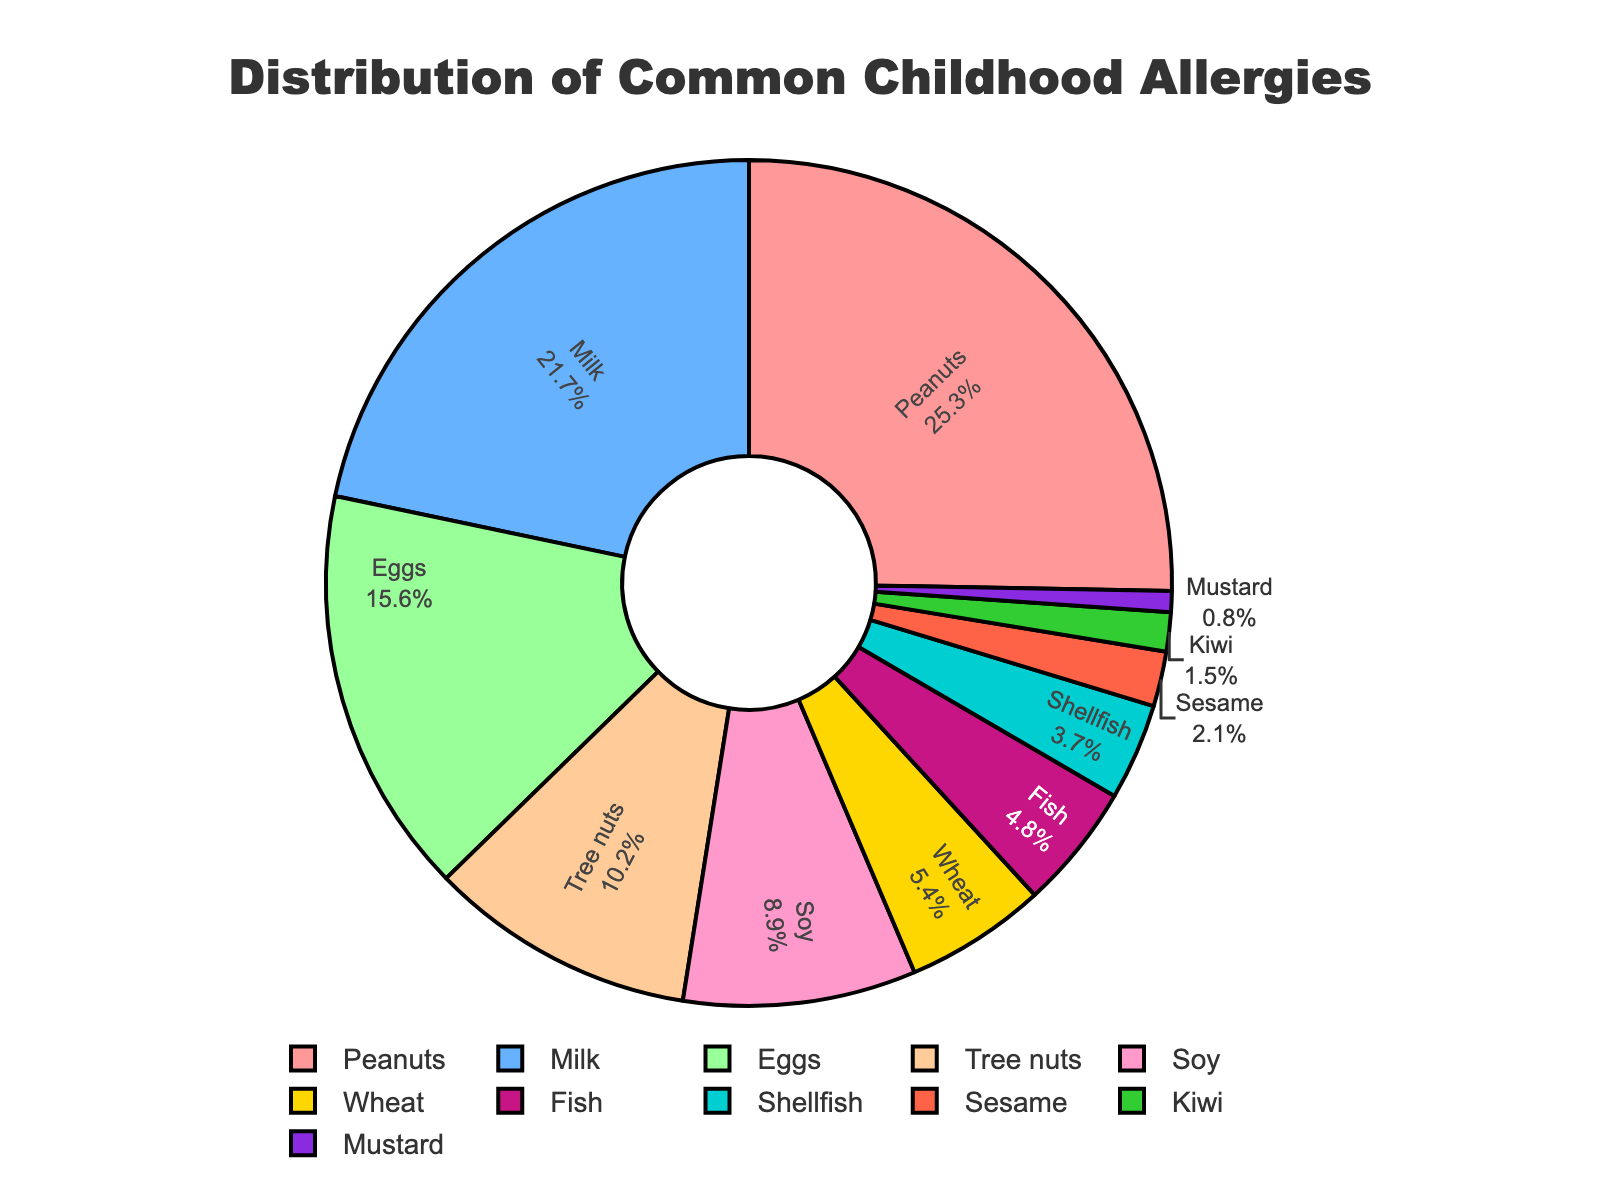What's the percentage of childhood allergies caused by peanuts and milk combined? To calculate the combined percentage, simply add the percentage values for peanuts and milk. Peanuts account for 25.3%, and milk accounts for 21.7%. So, the combined percentage is 25.3 + 21.7 = 47.0%.
Answer: 47.0% Which allergen has the lowest percentage? To determine the allergen with the lowest percentage, examine the percentages listed in the pie chart. Mustard has the lowest percentage at 0.8%.
Answer: Mustard How does the percentage of tree nut allergies compare to soy allergies? Compare the two percentages provided in the pie chart. Tree nuts account for 10.2%, whereas soy accounts for 8.9%. Therefore, the percentage of tree nut allergies is higher than soy allergies.
Answer: Tree nuts have a higher percentage Which allergens together make up more than 50% of childhood allergies? To identify the allergens that together account for more than 50%, start adding the largest percentages until the sum exceeds 50%. Combining peanuts (25.3%), milk (21.7%), and eggs (15.6%) gives 25.3 + 21.7 + 15.6 = 62.6%, which is over 50%.
Answer: Peanuts, milk, and eggs What is the third most common childhood allergen? Identify the allergen with the third highest percentage. The list shows that eggs, with 15.6%, are the third most common childhood allergen after peanuts and milk.
Answer: Eggs What is the difference in percentage between fish and shellfish allergies? Subtract the percentage of shellfish allergies from fish allergies. Fish have 4.8%, while shellfish have 3.7%. Thus, the difference is 4.8 - 3.7 = 1.1%.
Answer: 1.1% Is the percentage of wheat allergies higher or lower than sesame allergies? Compare the percentages of wheat (5.4%) and sesame (2.1%). Wheat has a higher percentage than sesame allergies.
Answer: Higher How many allergens in the chart have a percentage less than 5%? Count the allergens listed with percentages below 5%. There are four such allergens: fish (4.8%), shellfish (3.7%), sesame (2.1%), and mustard (0.8%).
Answer: 4 What visual attributes help distinguish the largest segment in the pie chart? The largest segment is typically visually prominent due to its size, color, and position. The segment for peanuts, which is the largest, is distinct due to its large proportion size and possibly a more prominent color.
Answer: Size and color Calculate the total percentage of allergies for soy, wheat, shellfish, and sesame. Add the percentage values for soy (8.9%), wheat (5.4%), shellfish (3.7%), and sesame (2.1%). The total is 8.9 + 5.4 + 3.7 + 2.1 = 20.1%.
Answer: 20.1% 